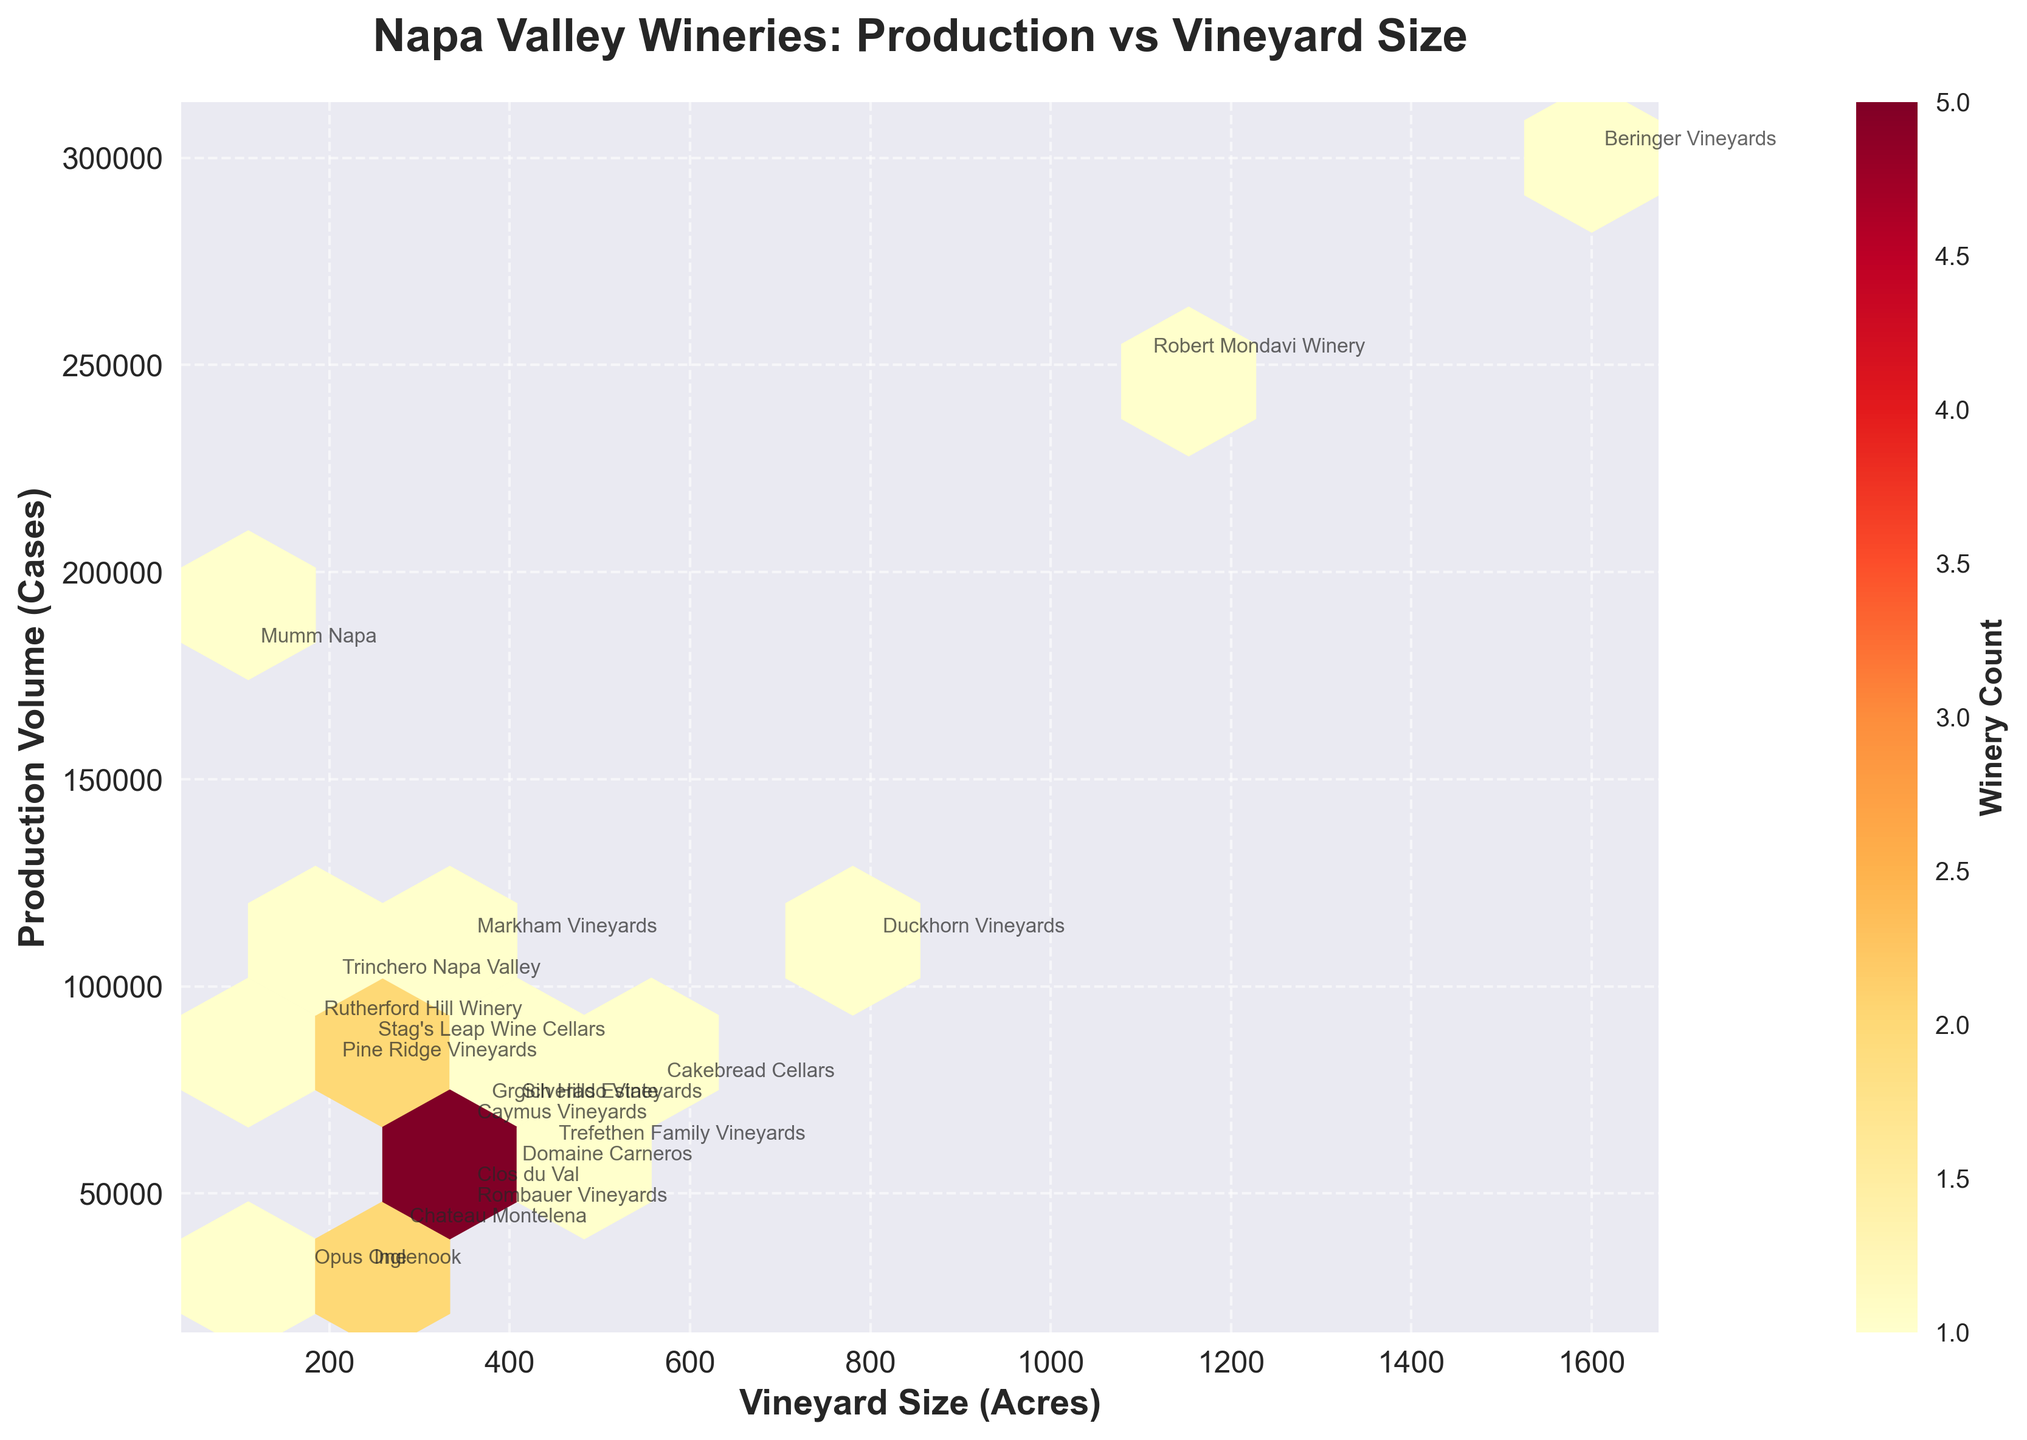What's the title of the figure? The title is located at the top of the figure and summarizes what the plot is about.
Answer: Napa Valley Wineries: Production vs Vineyard Size What does the color represent in the hexbin plot? The color in a hexbin plot indicates the density or count of wineries within a particular region of production volume and vineyard size. The color bar explains the density, ranging from light to dark.
Answer: Count of wineries Which winery has the highest production volume? The highest production volume is the point positioned furthest along the y-axis. Annotating texts help identify specific wineries.
Answer: Beringer Vineyards How many wineries produce more than 100,000 cases of wine annually? Count all the data points above the 100,000 cases mark on the y-axis, referring to the annotations. Check each corresponding text label.
Answer: 4 What is the range of vineyard sizes represented in the plot? The x-axis shows the vineyard sizes. The smallest and largest values labeled on this axis give us the range.
Answer: 110 to 1600 acres Which winery has the largest vineyard size? The largest vineyard size is the point positioned furthest along the x-axis. Text annotations identify specific wineries.
Answer: Beringer Vineyards Are there more wineries with production volumes below or above 100,000 cases? To determine this, visually inspect the number of hexagons or points above and below 100,000 cases on the y-axis. Compare the counts from each side.
Answer: Below What is the average production volume of the wineries listed? Sum all production volumes given and divide by the number of wineries listed. Using numerical values from the table, calculate the total and then divide.
Answer: 88421 cases Which wineries have both vineyard sizes and production volumes below their respective median values? Determine median vineyard size and production volume, then locate wineries below these medians. Manually compare each winery's values to these medians.
Answer: Chateau Montelena, Opus One Do any wineries produce more wine with smaller vineyard sizes than others with larger vineyard sizes? Compare production volumes along the same hexagon bins; smaller vineyards with higher volumes than larger ones in lower producing bins fit the criteria. Examine annotated data points for confirmation.
Answer: Yes, Mumm Napa produces more than some with larger vineyards 